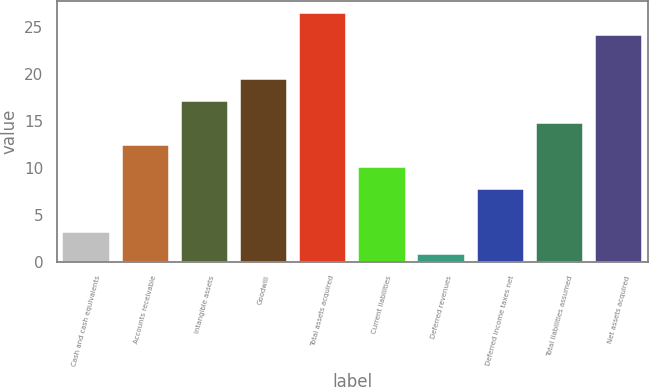Convert chart. <chart><loc_0><loc_0><loc_500><loc_500><bar_chart><fcel>Cash and cash equivalents<fcel>Accounts receivable<fcel>Intangible assets<fcel>Goodwill<fcel>Total assets acquired<fcel>Current liabilities<fcel>Deferred revenues<fcel>Deferred income taxes net<fcel>Total liabilities assumed<fcel>Net assets acquired<nl><fcel>3.14<fcel>12.5<fcel>17.18<fcel>19.52<fcel>26.54<fcel>10.16<fcel>0.8<fcel>7.82<fcel>14.84<fcel>24.2<nl></chart> 